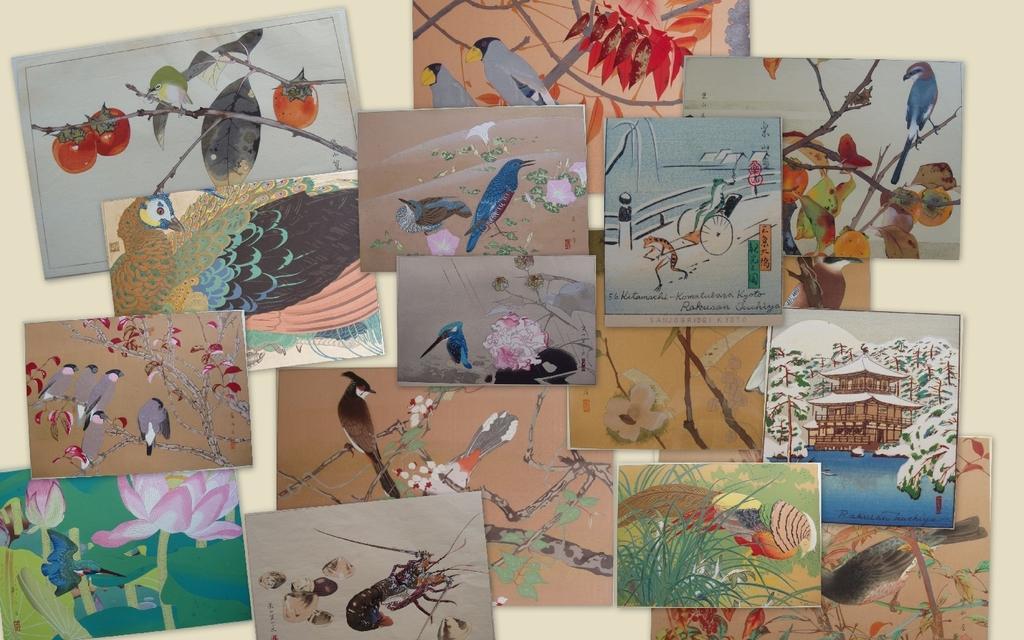Can you describe this image briefly? In this image I can see there are lot of painted pictures of birds and different animals. 